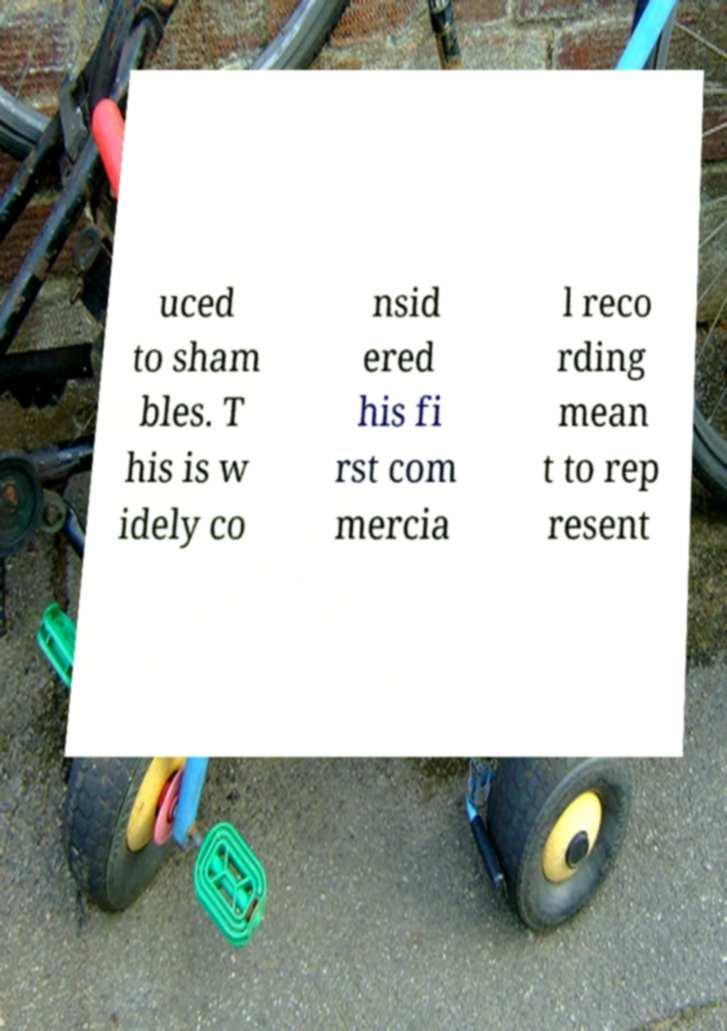Please identify and transcribe the text found in this image. uced to sham bles. T his is w idely co nsid ered his fi rst com mercia l reco rding mean t to rep resent 